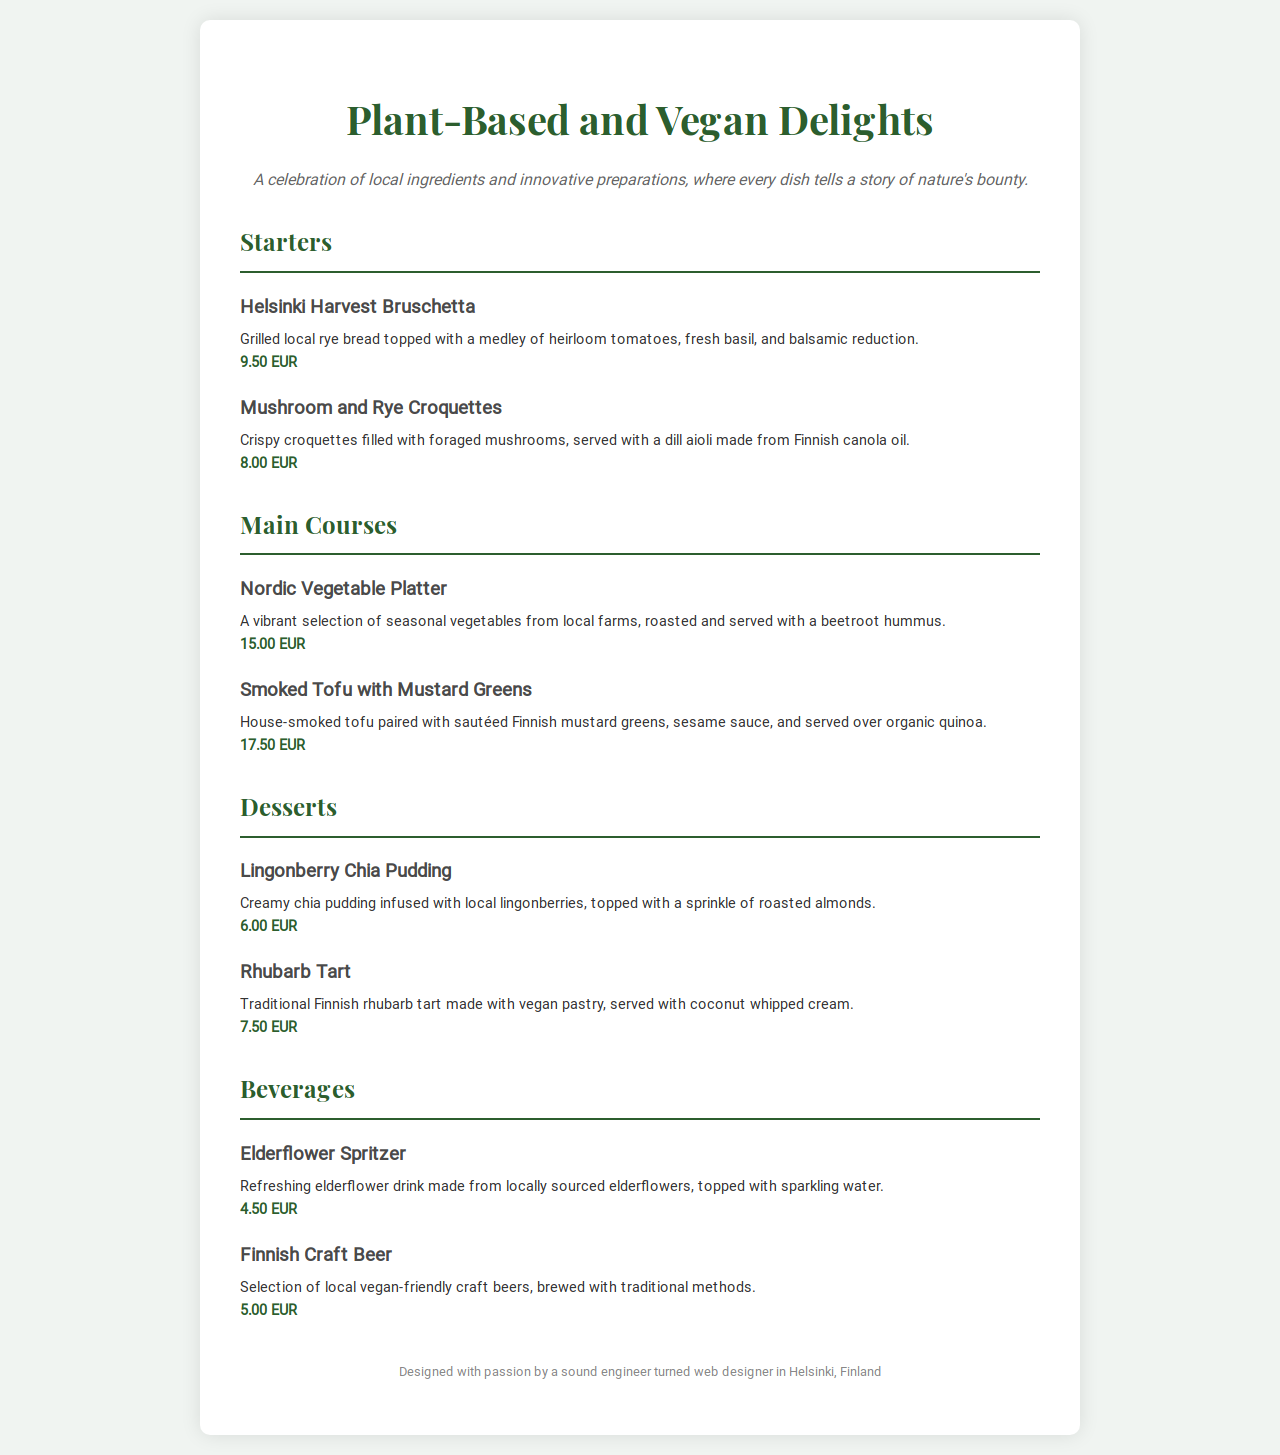What is the price of Helsinki Harvest Bruschetta? The price is stated next to the menu item in euros.
Answer: 9.50 EUR What type of bread is used in the Helsinki Harvest Bruschetta? The document specifies that local rye bread is used for the bruschetta.
Answer: rye bread How much does the Smoked Tofu with Mustard Greens cost? The price is listed below the dish description, which is necessary for ordering.
Answer: 17.50 EUR What dessert is made with local lingonberries? This dessert is explicitly mentioned in the desserts section of the menu.
Answer: Lingonberry Chia Pudding Which beverage is made from locally sourced elderflowers? The beverage is specified in the beverages section of the menu with its key ingredient.
Answer: Elderflower Spritzer What is a common ingredient for the Mushroom and Rye Croquettes? The essential component described in the item is crucial for understanding its flavor.
Answer: foraged mushrooms Which two dishes feature beetroot? These items require reasoning to identify those connected by the common ingredient beetroot.
Answer: Nordic Vegetable Platter, Smoked Tofu with Mustard Greens What is the maximum price listed on the menu? Finding the highest price requires assessing all menu items to determine the cost.
Answer: 17.50 EUR 